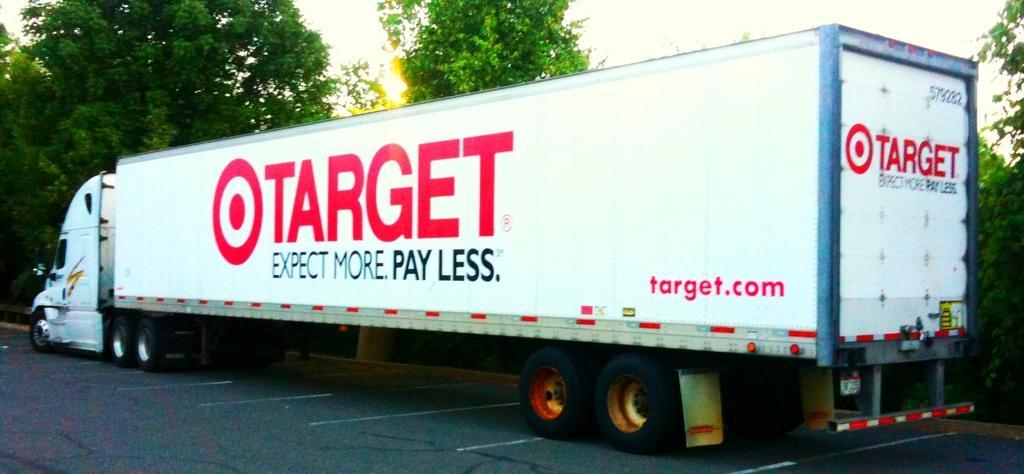Could you give a brief overview of what you see in this image? At the bottom it is road. In the middle there are trees and a truck. At the top it is sky. 